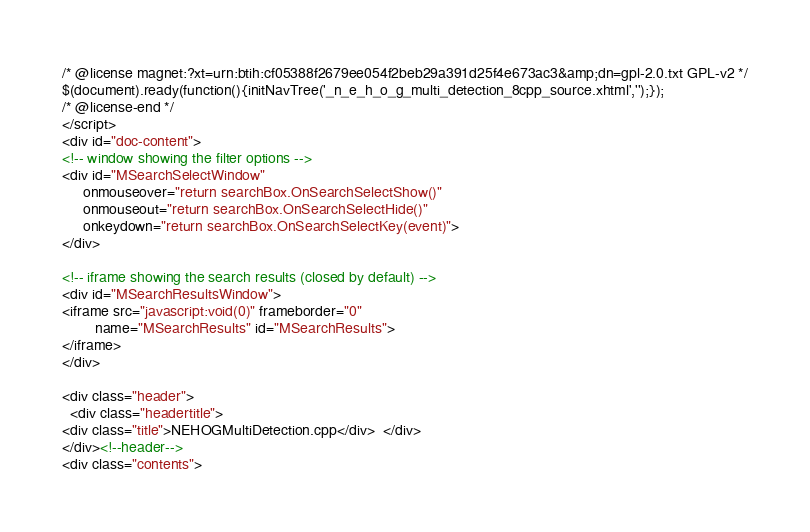<code> <loc_0><loc_0><loc_500><loc_500><_HTML_>/* @license magnet:?xt=urn:btih:cf05388f2679ee054f2beb29a391d25f4e673ac3&amp;dn=gpl-2.0.txt GPL-v2 */
$(document).ready(function(){initNavTree('_n_e_h_o_g_multi_detection_8cpp_source.xhtml','');});
/* @license-end */
</script>
<div id="doc-content">
<!-- window showing the filter options -->
<div id="MSearchSelectWindow"
     onmouseover="return searchBox.OnSearchSelectShow()"
     onmouseout="return searchBox.OnSearchSelectHide()"
     onkeydown="return searchBox.OnSearchSelectKey(event)">
</div>

<!-- iframe showing the search results (closed by default) -->
<div id="MSearchResultsWindow">
<iframe src="javascript:void(0)" frameborder="0" 
        name="MSearchResults" id="MSearchResults">
</iframe>
</div>

<div class="header">
  <div class="headertitle">
<div class="title">NEHOGMultiDetection.cpp</div>  </div>
</div><!--header-->
<div class="contents"></code> 